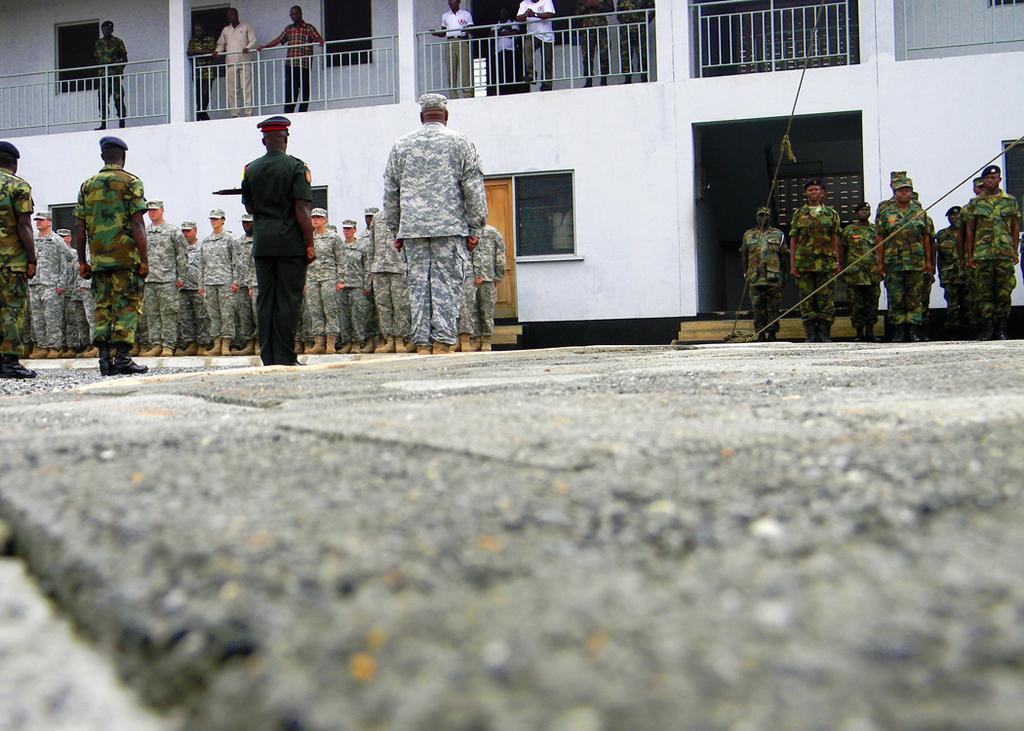Can you describe this image briefly? At the bottom of the picture, we see the road, On either side of the picture, we see men in uniforms are standing. Behind them, we see a white building, window and a door. There are people standing beside the railing. Behind them, we see windows and a white wall. 